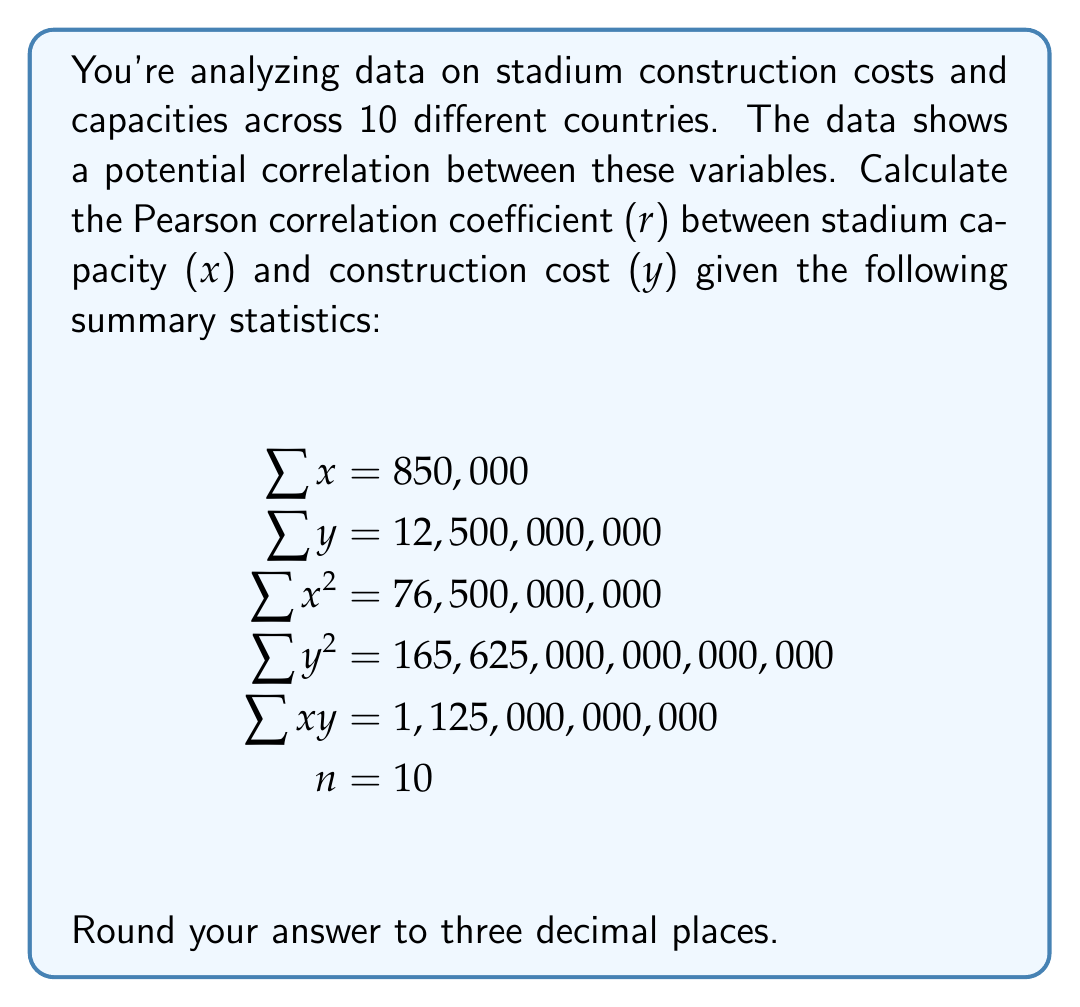What is the answer to this math problem? To calculate the Pearson correlation coefficient (r), we'll use the formula:

$$r = \frac{n\sum xy - \sum x \sum y}{\sqrt{[n\sum x^2 - (\sum x)^2][n\sum y^2 - (\sum y)^2]}}$$

Let's break this down step-by-step:

1) First, calculate $n\sum xy$:
   $10 \times 1,125,000,000,000 = 11,250,000,000,000$

2) Calculate $\sum x \sum y$:
   $850,000 \times 12,500,000,000 = 10,625,000,000,000$

3) Calculate the numerator:
   $11,250,000,000,000 - 10,625,000,000,000 = 625,000,000,000$

4) For the denominator, first calculate $n\sum x^2$:
   $10 \times 76,500,000,000 = 765,000,000,000$

5) Calculate $(\sum x)^2$:
   $850,000^2 = 722,500,000,000$

6) Calculate $n\sum y^2$:
   $10 \times 165,625,000,000,000,000 = 1,656,250,000,000,000,000$

7) Calculate $(\sum y)^2$:
   $12,500,000,000^2 = 156,250,000,000,000,000$

8) Now, calculate the two parts of the denominator:
   $[765,000,000,000 - 722,500,000,000] = 42,500,000,000$
   $[1,656,250,000,000,000,000 - 156,250,000,000,000,000] = 1,500,000,000,000,000,000$

9) Multiply these parts:
   $42,500,000,000 \times 1,500,000,000,000,000,000 = 63,750,000,000,000,000,000,000,000$

10) Take the square root:
    $\sqrt{63,750,000,000,000,000,000,000,000} = 7,984,375,000,000$

11) Finally, divide the numerator by the denominator:
    $\frac{625,000,000,000}{7,984,375,000,000} \approx 0.078275$

12) Rounding to three decimal places gives us 0.078.
Answer: 0.078 